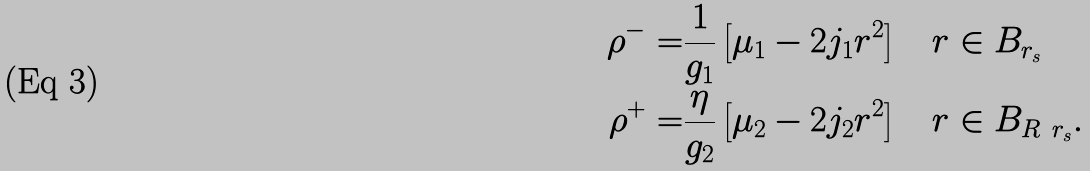<formula> <loc_0><loc_0><loc_500><loc_500>\rho ^ { - } = & \frac { 1 } { g _ { 1 } } \left [ \mu _ { 1 } - 2 j _ { 1 } r ^ { 2 } \right ] \quad r \in B _ { r _ { s } } \\ \rho ^ { + } = & \frac { \eta } { g _ { 2 } } \left [ \mu _ { 2 } - 2 j _ { 2 } r ^ { 2 } \right ] \quad r \in B _ { R \ r _ { s } } .</formula> 